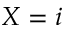Convert formula to latex. <formula><loc_0><loc_0><loc_500><loc_500>X = i</formula> 